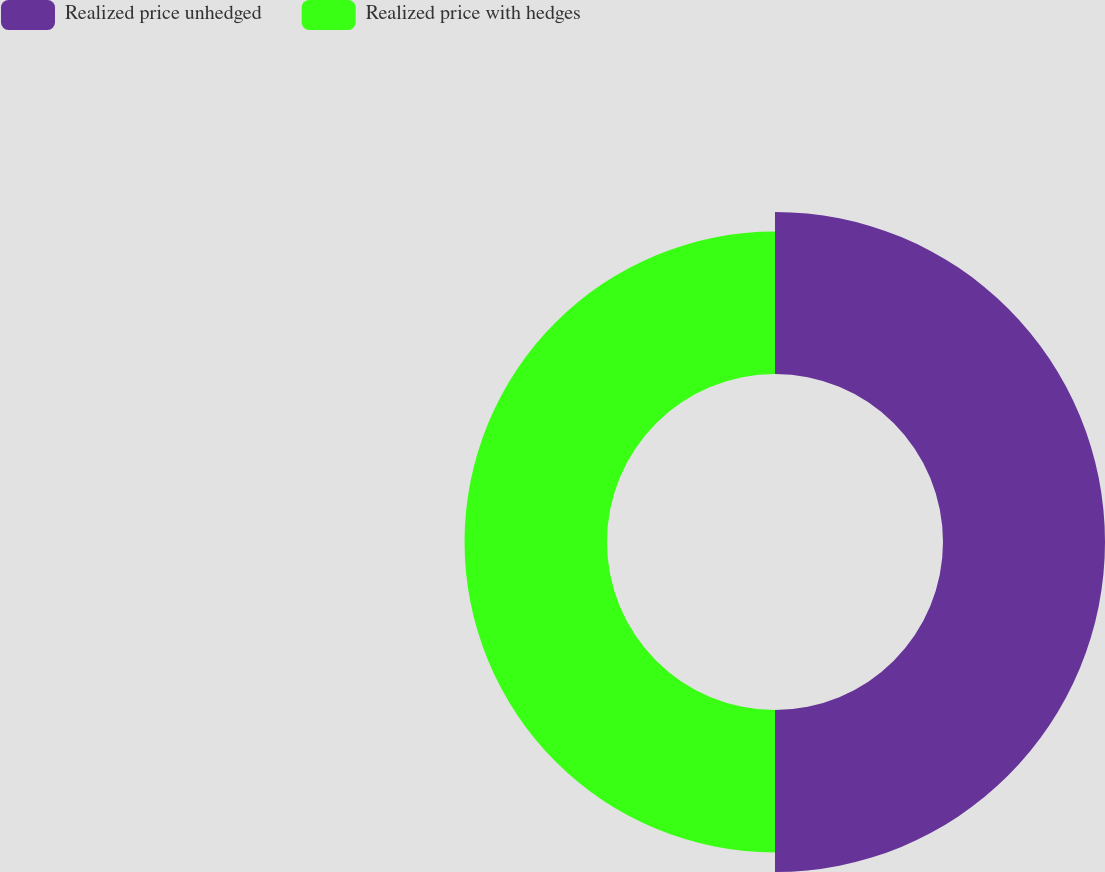Convert chart. <chart><loc_0><loc_0><loc_500><loc_500><pie_chart><fcel>Realized price unhedged<fcel>Realized price with hedges<nl><fcel>53.21%<fcel>46.79%<nl></chart> 